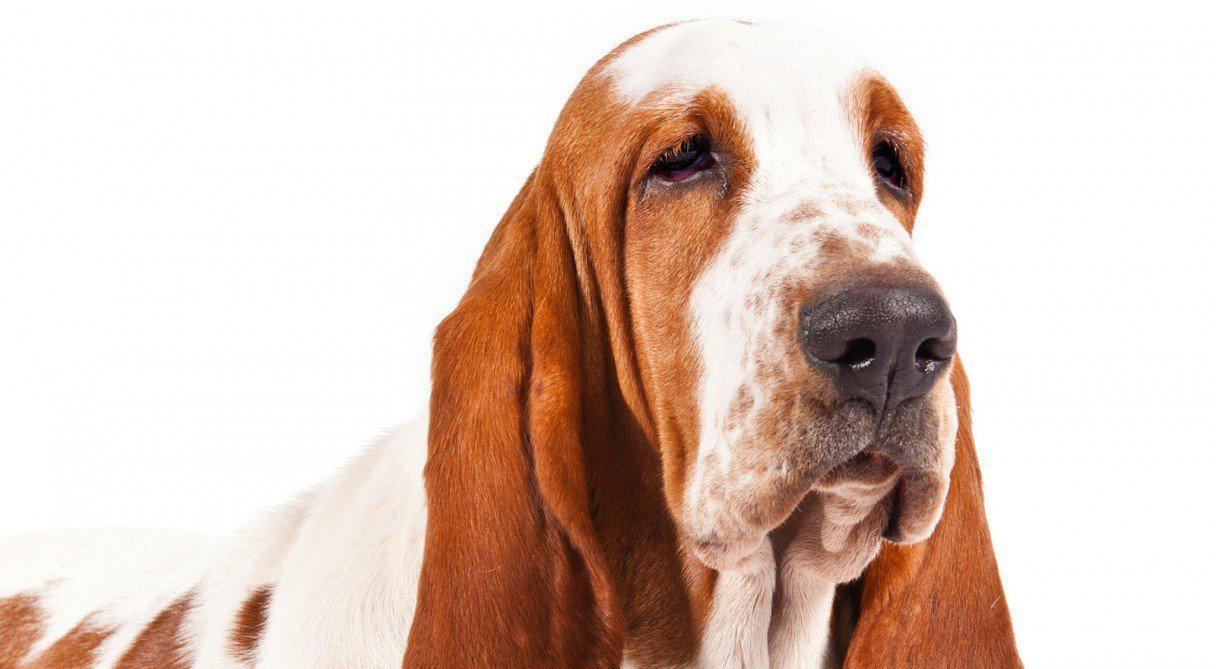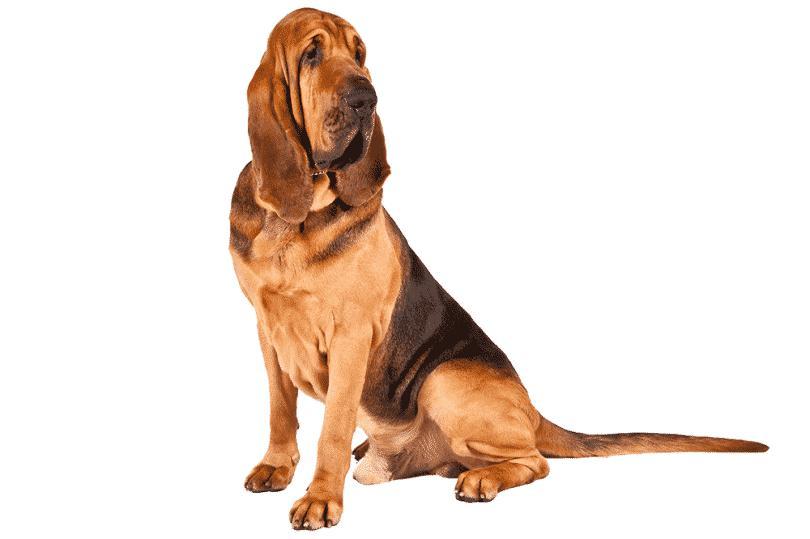The first image is the image on the left, the second image is the image on the right. Examine the images to the left and right. Is the description "There are at least two dogs in the image on the right." accurate? Answer yes or no. No. 